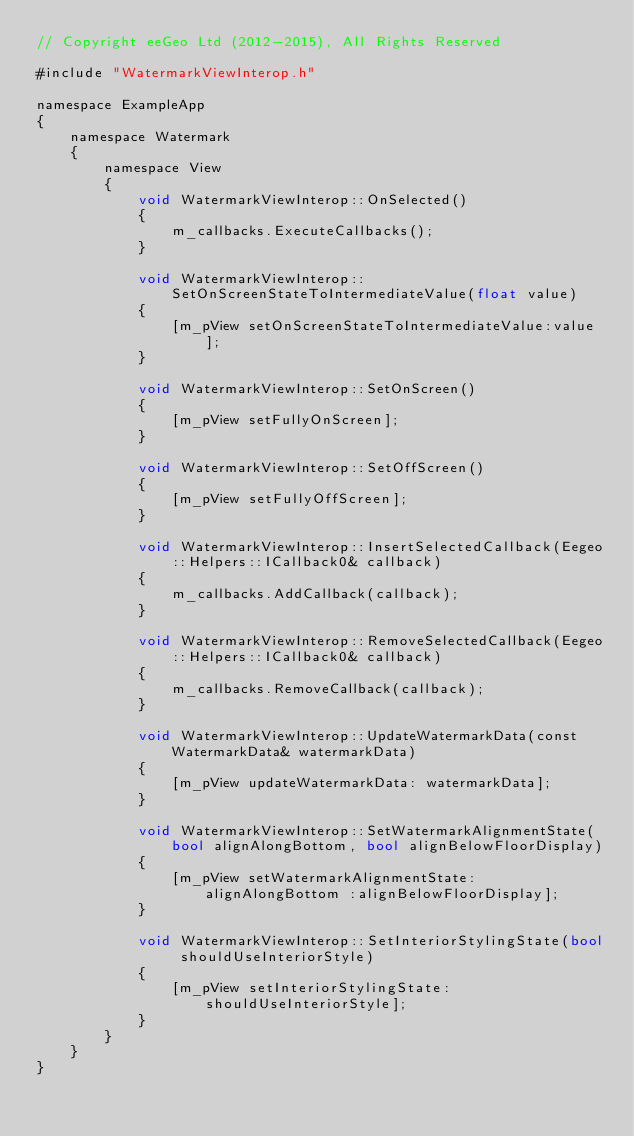Convert code to text. <code><loc_0><loc_0><loc_500><loc_500><_ObjectiveC_>// Copyright eeGeo Ltd (2012-2015), All Rights Reserved

#include "WatermarkViewInterop.h"

namespace ExampleApp
{
    namespace Watermark
    {
        namespace View
        {
            void WatermarkViewInterop::OnSelected()
            {
                m_callbacks.ExecuteCallbacks();
            }

            void WatermarkViewInterop::SetOnScreenStateToIntermediateValue(float value)
            {
                [m_pView setOnScreenStateToIntermediateValue:value];
            }

            void WatermarkViewInterop::SetOnScreen()
            {
                [m_pView setFullyOnScreen];
            }

            void WatermarkViewInterop::SetOffScreen()
            {
                [m_pView setFullyOffScreen];
            }

            void WatermarkViewInterop::InsertSelectedCallback(Eegeo::Helpers::ICallback0& callback)
            {
                m_callbacks.AddCallback(callback);
            }

            void WatermarkViewInterop::RemoveSelectedCallback(Eegeo::Helpers::ICallback0& callback)
            {
                m_callbacks.RemoveCallback(callback);
            }
            
            void WatermarkViewInterop::UpdateWatermarkData(const WatermarkData& watermarkData)
            {
                [m_pView updateWatermarkData: watermarkData];
            }
            
            void WatermarkViewInterop::SetWatermarkAlignmentState(bool alignAlongBottom, bool alignBelowFloorDisplay)
            {
                [m_pView setWatermarkAlignmentState:alignAlongBottom :alignBelowFloorDisplay];
            }
            
            void WatermarkViewInterop::SetInteriorStylingState(bool shouldUseInteriorStyle)
            {
                [m_pView setInteriorStylingState:shouldUseInteriorStyle];
            }
        }
    }
}
</code> 